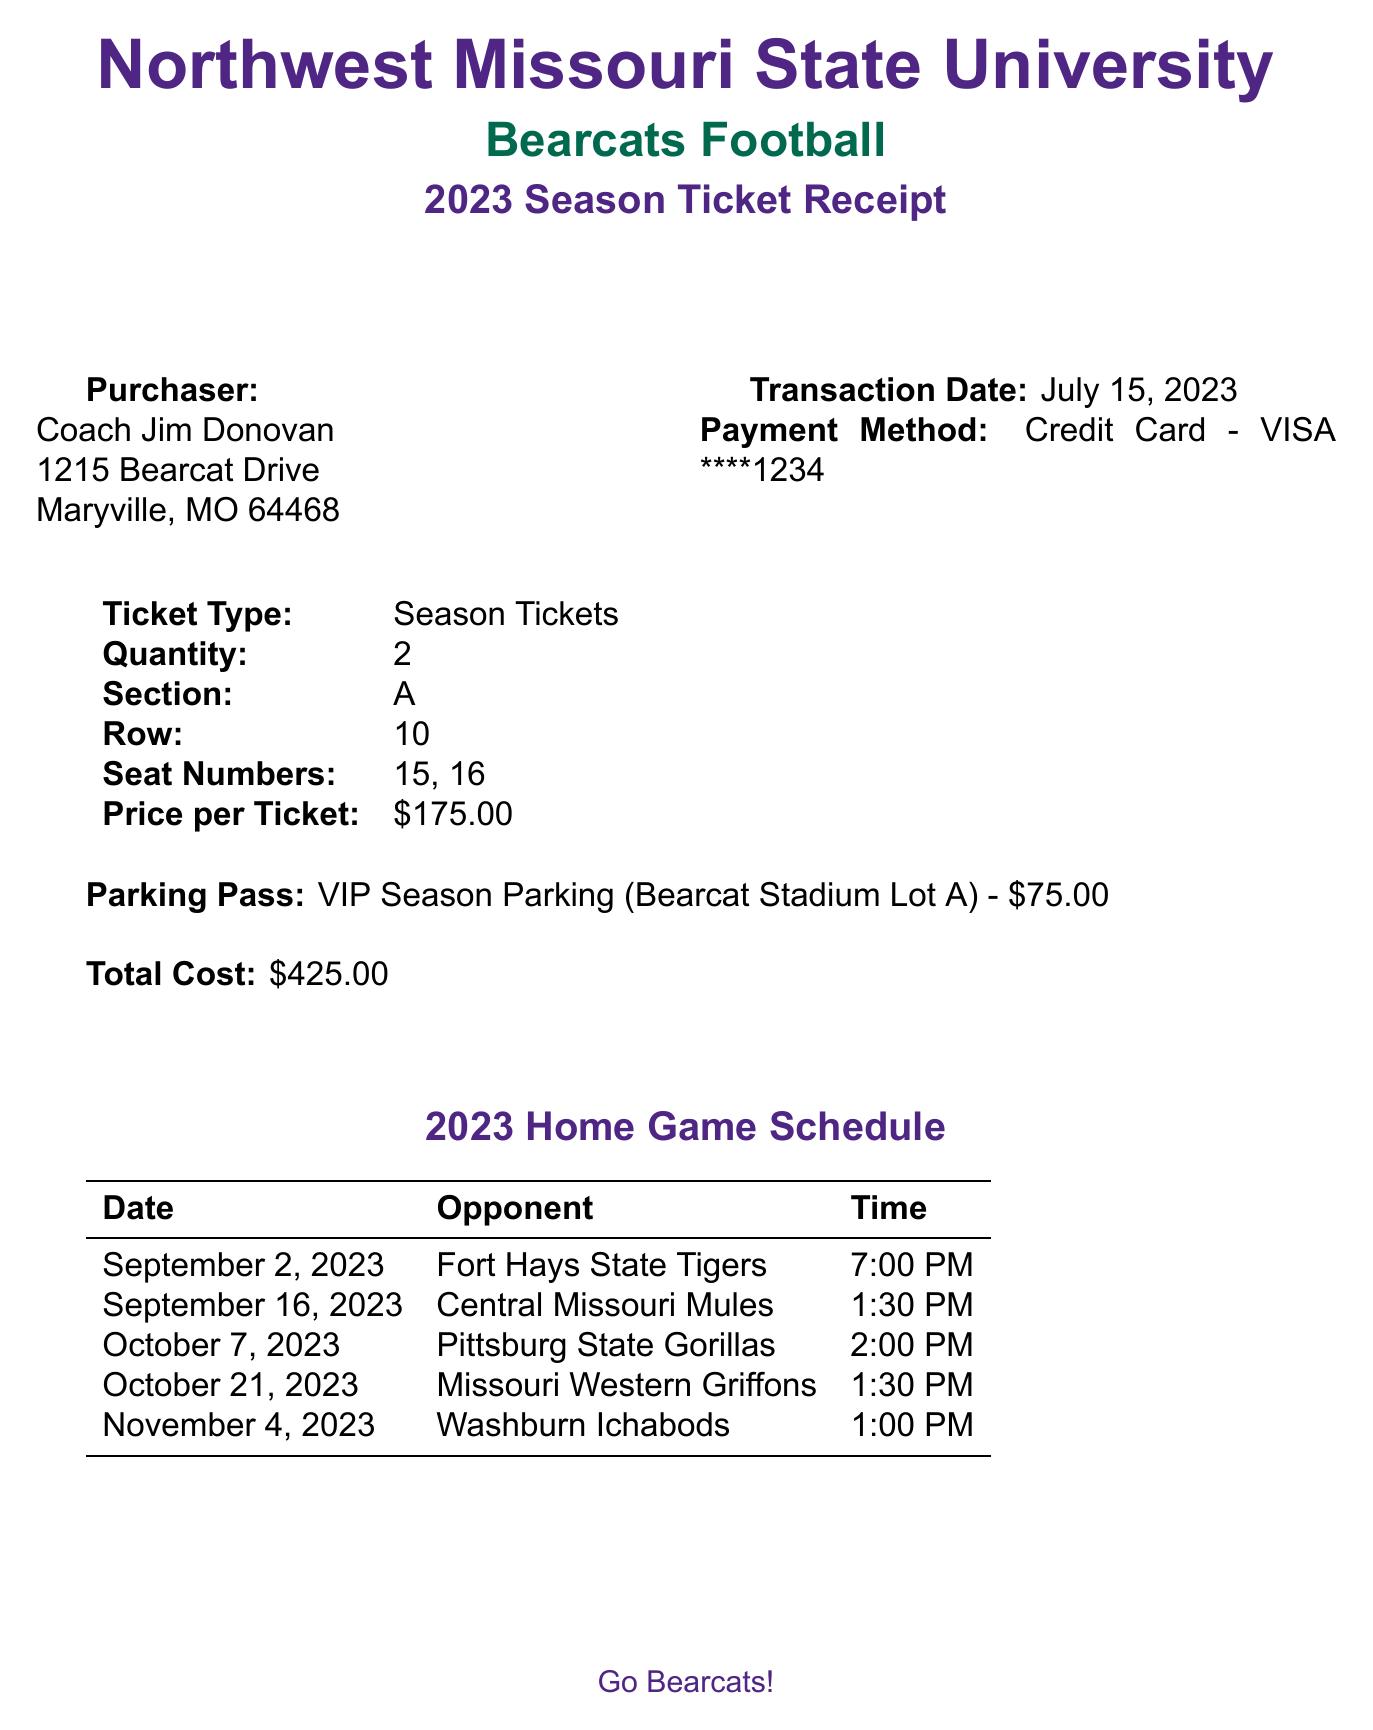What is the name of the university? The document states the university as Northwest Missouri State University.
Answer: Northwest Missouri State University Who is the purchaser of the season tickets? The purchaser's name is mentioned in the document as Coach Jim Donovan.
Answer: Coach Jim Donovan How many season tickets were purchased? The document specifies the quantity of season tickets purchased as 2.
Answer: 2 What is the total cost of the season tickets and parking pass? The total cost is calculated from the ticket price and parking pass, which is $425.00.
Answer: $425.00 What is the date of the pre-season meet-and-greet invitation? The special note indicates the invitation for the meet-and-greet is on August 20, 2023.
Answer: August 20, 2023 What parking lot is designated for the VIP season parking pass? The document mentions Bearcat Stadium Lot A as the designated parking lot.
Answer: Bearcat Stadium Lot A Which team will the Bearcats face on October 21, 2023? The document lists the opponent on that date as Missouri Western Griffons.
Answer: Missouri Western Griffons What is the price per ticket? The ticket price per individual ticket is listed in the document as $175.00.
Answer: $175.00 